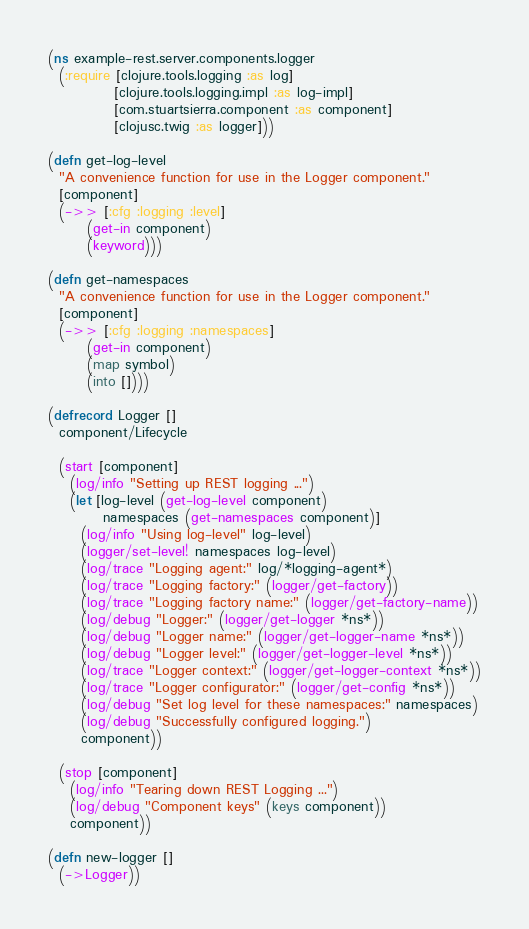<code> <loc_0><loc_0><loc_500><loc_500><_Clojure_>(ns example-rest.server.components.logger
  (:require [clojure.tools.logging :as log]
            [clojure.tools.logging.impl :as log-impl]
            [com.stuartsierra.component :as component]
            [clojusc.twig :as logger]))

(defn get-log-level
  "A convenience function for use in the Logger component."
  [component]
  (->> [:cfg :logging :level]
       (get-in component)
       (keyword)))

(defn get-namespaces
  "A convenience function for use in the Logger component."
  [component]
  (->> [:cfg :logging :namespaces]
       (get-in component)
       (map symbol)
       (into [])))

(defrecord Logger []
  component/Lifecycle

  (start [component]
    (log/info "Setting up REST logging ...")
    (let [log-level (get-log-level component)
          namespaces (get-namespaces component)]
      (log/info "Using log-level" log-level)
      (logger/set-level! namespaces log-level)
      (log/trace "Logging agent:" log/*logging-agent*)
      (log/trace "Logging factory:" (logger/get-factory))
      (log/trace "Logging factory name:" (logger/get-factory-name))
      (log/debug "Logger:" (logger/get-logger *ns*))
      (log/debug "Logger name:" (logger/get-logger-name *ns*))
      (log/debug "Logger level:" (logger/get-logger-level *ns*))
      (log/trace "Logger context:" (logger/get-logger-context *ns*))
      (log/trace "Logger configurator:" (logger/get-config *ns*))
      (log/debug "Set log level for these namespaces:" namespaces)
      (log/debug "Successfully configured logging.")
      component))

  (stop [component]
    (log/info "Tearing down REST Logging ...")
    (log/debug "Component keys" (keys component))
    component))

(defn new-logger []
  (->Logger))
</code> 